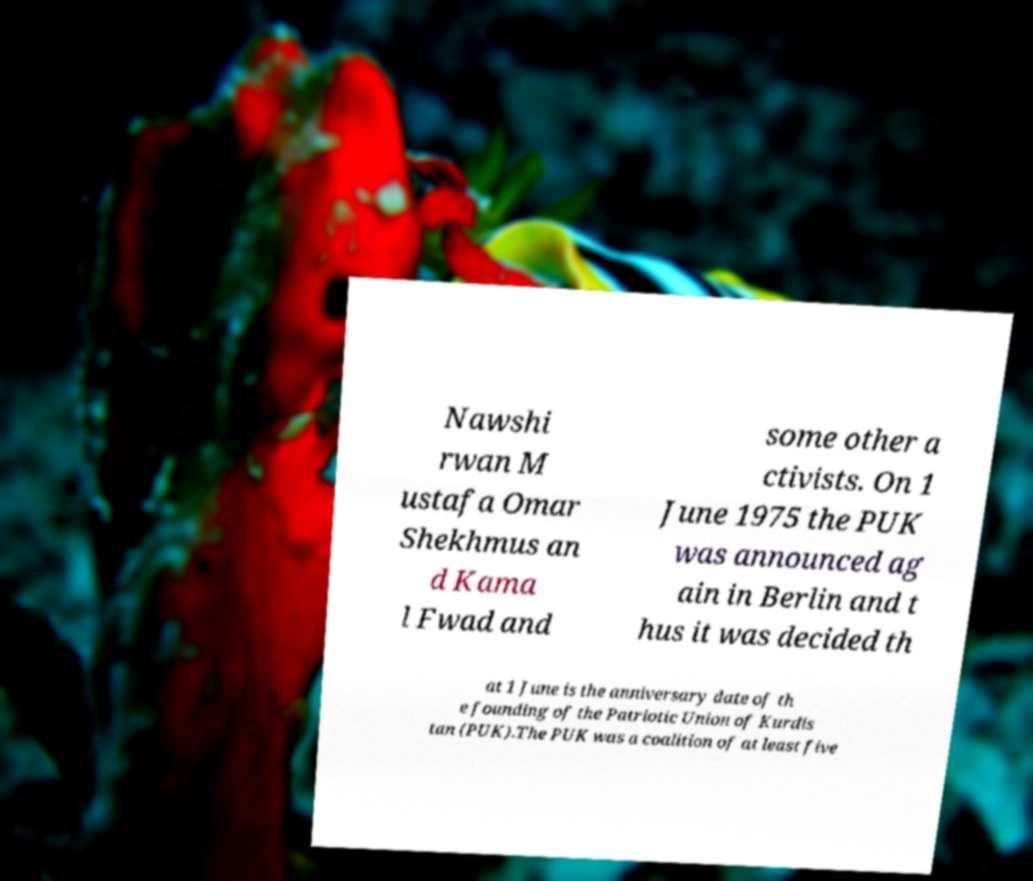Can you read and provide the text displayed in the image?This photo seems to have some interesting text. Can you extract and type it out for me? Nawshi rwan M ustafa Omar Shekhmus an d Kama l Fwad and some other a ctivists. On 1 June 1975 the PUK was announced ag ain in Berlin and t hus it was decided th at 1 June is the anniversary date of th e founding of the Patriotic Union of Kurdis tan (PUK).The PUK was a coalition of at least five 